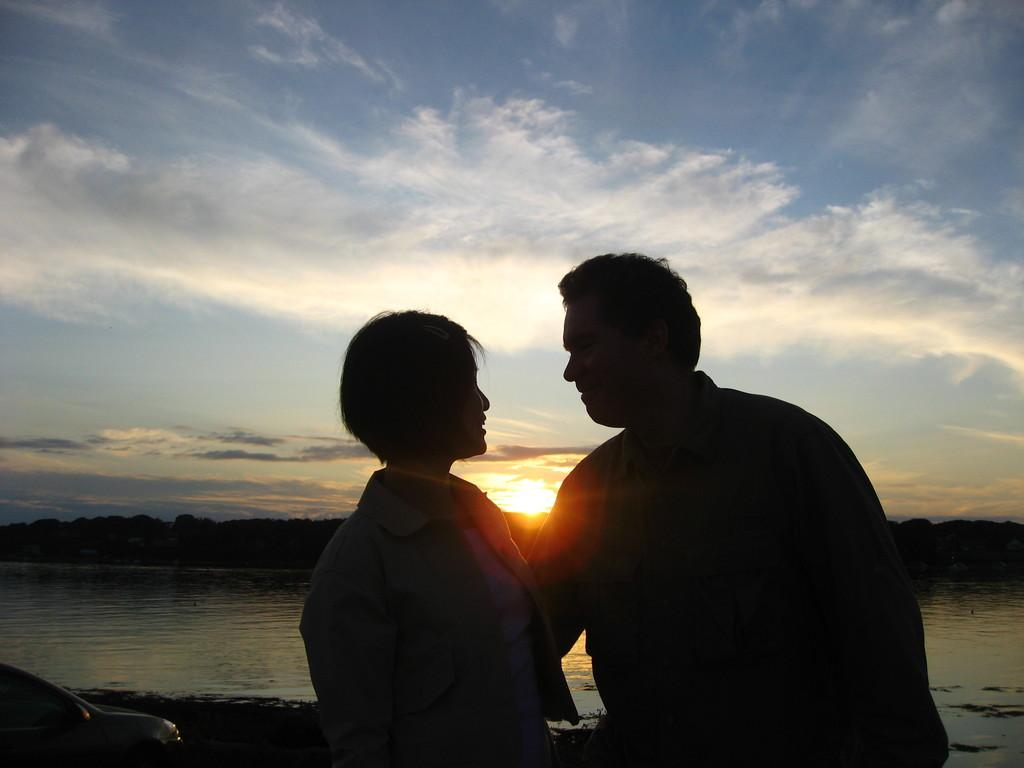How many people are present in the image? There are two people in the image. What can be seen in the image besides the people? There is an object in the image. What is visible in the background of the image? Water, trees, the sun, and clouds are visible in the background of the image. What type of mark can be seen on the slope in the image? There is no slope or mark present in the image. What channel is being used by the people in the image? There is no channel mentioned or visible in the image. 